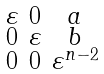Convert formula to latex. <formula><loc_0><loc_0><loc_500><loc_500>\begin{smallmatrix} \varepsilon & 0 & a \\ 0 & \varepsilon & b \\ 0 & 0 & \varepsilon ^ { n - 2 } \end{smallmatrix}</formula> 